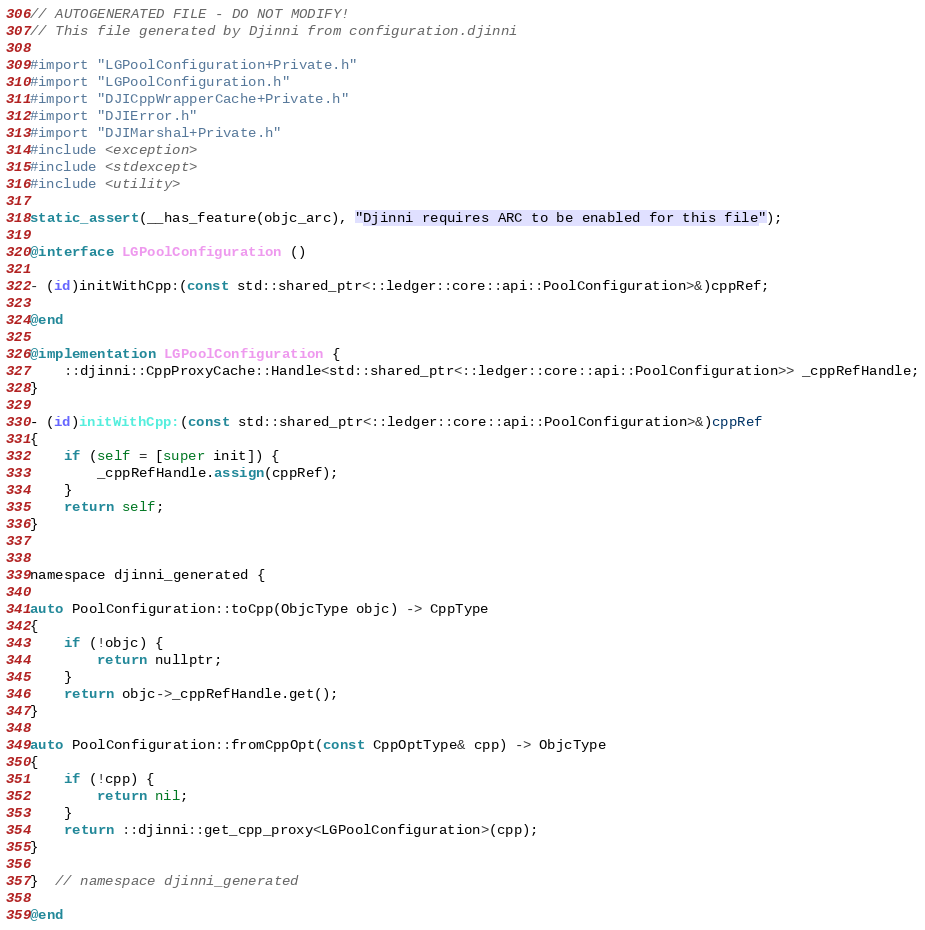Convert code to text. <code><loc_0><loc_0><loc_500><loc_500><_ObjectiveC_>// AUTOGENERATED FILE - DO NOT MODIFY!
// This file generated by Djinni from configuration.djinni

#import "LGPoolConfiguration+Private.h"
#import "LGPoolConfiguration.h"
#import "DJICppWrapperCache+Private.h"
#import "DJIError.h"
#import "DJIMarshal+Private.h"
#include <exception>
#include <stdexcept>
#include <utility>

static_assert(__has_feature(objc_arc), "Djinni requires ARC to be enabled for this file");

@interface LGPoolConfiguration ()

- (id)initWithCpp:(const std::shared_ptr<::ledger::core::api::PoolConfiguration>&)cppRef;

@end

@implementation LGPoolConfiguration {
    ::djinni::CppProxyCache::Handle<std::shared_ptr<::ledger::core::api::PoolConfiguration>> _cppRefHandle;
}

- (id)initWithCpp:(const std::shared_ptr<::ledger::core::api::PoolConfiguration>&)cppRef
{
    if (self = [super init]) {
        _cppRefHandle.assign(cppRef);
    }
    return self;
}


namespace djinni_generated {

auto PoolConfiguration::toCpp(ObjcType objc) -> CppType
{
    if (!objc) {
        return nullptr;
    }
    return objc->_cppRefHandle.get();
}

auto PoolConfiguration::fromCppOpt(const CppOptType& cpp) -> ObjcType
{
    if (!cpp) {
        return nil;
    }
    return ::djinni::get_cpp_proxy<LGPoolConfiguration>(cpp);
}

}  // namespace djinni_generated

@end
</code> 